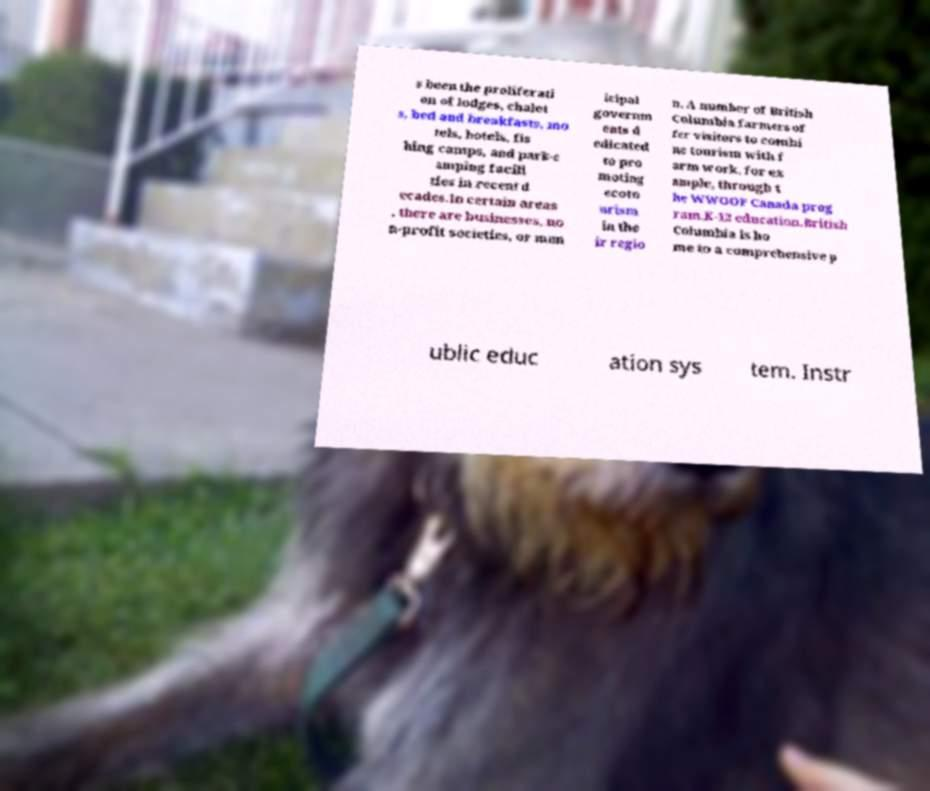Please identify and transcribe the text found in this image. s been the proliferati on of lodges, chalet s, bed and breakfasts, mo tels, hotels, fis hing camps, and park-c amping facili ties in recent d ecades.In certain areas , there are businesses, no n-profit societies, or mun icipal governm ents d edicated to pro moting ecoto urism in the ir regio n. A number of British Columbia farmers of fer visitors to combi ne tourism with f arm work, for ex ample, through t he WWOOF Canada prog ram.K-12 education.British Columbia is ho me to a comprehensive p ublic educ ation sys tem. Instr 